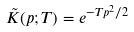Convert formula to latex. <formula><loc_0><loc_0><loc_500><loc_500>\tilde { K } ( p ; T ) = e ^ { - T p ^ { 2 } / 2 }</formula> 